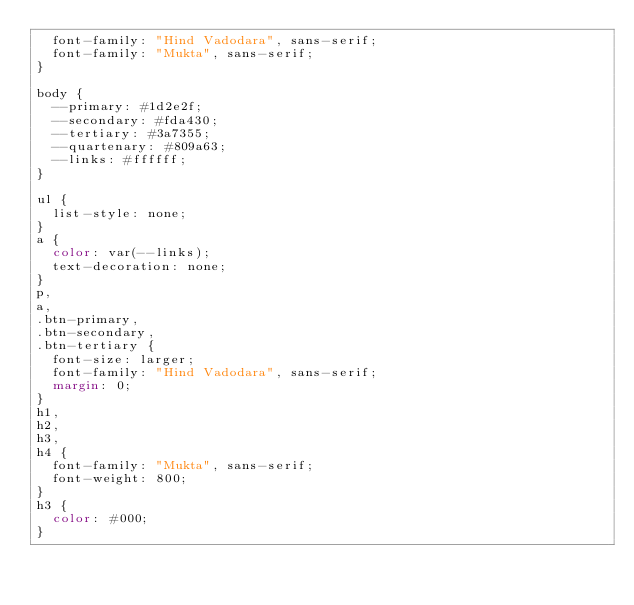Convert code to text. <code><loc_0><loc_0><loc_500><loc_500><_CSS_>  font-family: "Hind Vadodara", sans-serif;
  font-family: "Mukta", sans-serif;
}

body {
  --primary: #1d2e2f;
  --secondary: #fda430;
  --tertiary: #3a7355;
  --quartenary: #809a63;
  --links: #ffffff;
}

ul {
  list-style: none;
}
a {
  color: var(--links);
  text-decoration: none;
}
p,
a,
.btn-primary,
.btn-secondary,
.btn-tertiary {
  font-size: larger;
  font-family: "Hind Vadodara", sans-serif;
  margin: 0;
}
h1,
h2,
h3,
h4 {
  font-family: "Mukta", sans-serif;
  font-weight: 800;
}
h3 {
  color: #000;
}
</code> 